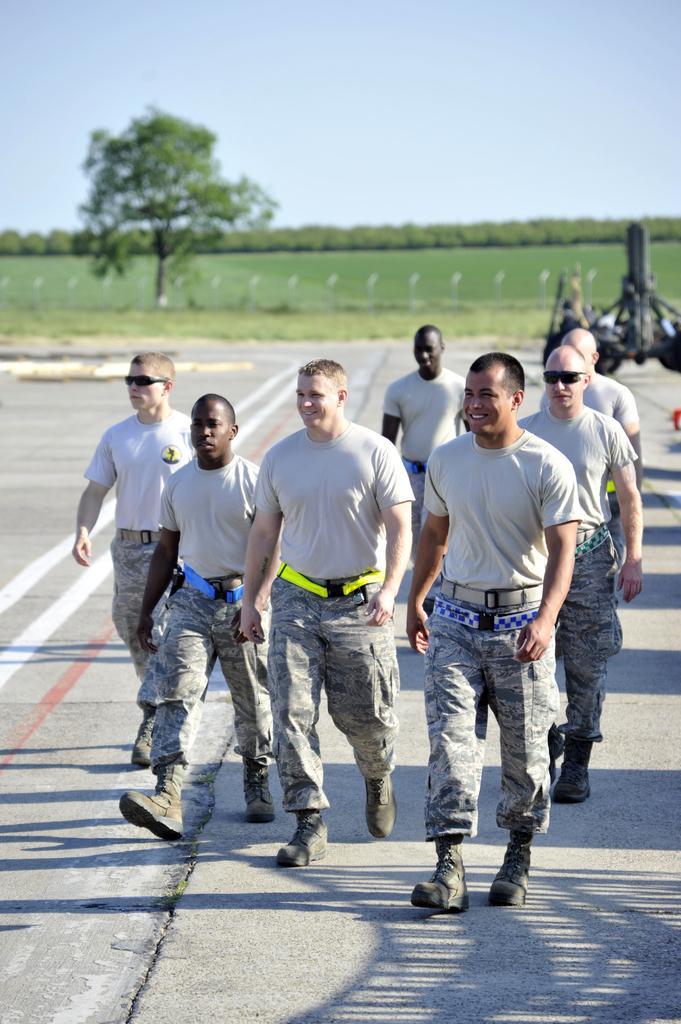Describe this image in one or two sentences. In this picture I can see some people are wearing t-shirt, trouser and shoes. They are walking on the road. In the background I can see the farmland, trees, plants, fencing and grass. At the top I can see the sky. 